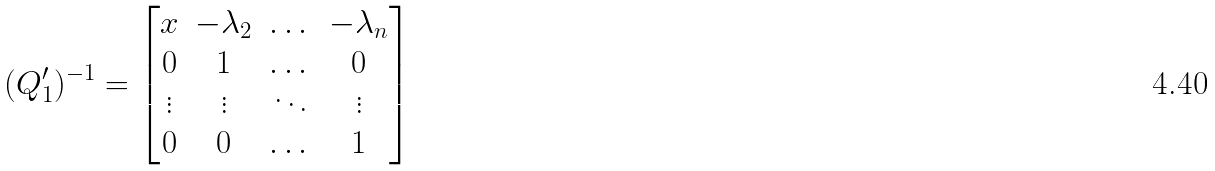Convert formula to latex. <formula><loc_0><loc_0><loc_500><loc_500>( Q _ { 1 } ^ { \prime } ) ^ { - 1 } = \begin{bmatrix} x & - \lambda _ { 2 } & \dots & - \lambda _ { n } \\ 0 & 1 & \dots & 0 \\ \vdots & \vdots & \ddots & \vdots \\ 0 & 0 & \dots & 1 \end{bmatrix}</formula> 